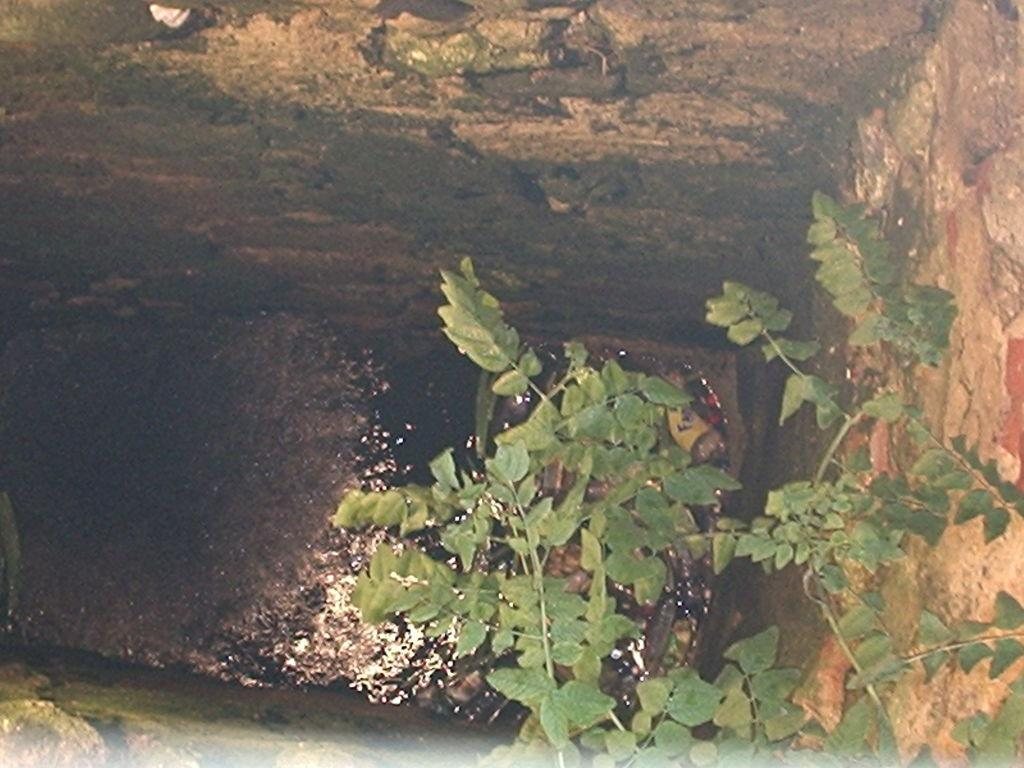What type of living organism can be seen in the image? There is a plant in the image. What is the primary element visible in the image? There is water visible in the image. What type of structure can be seen in the image? There are walls visible in the image. Where is the kitten playing in the dirt in the image? There is no kitten or dirt present in the image. 